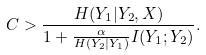Convert formula to latex. <formula><loc_0><loc_0><loc_500><loc_500>C > \frac { H ( Y _ { 1 } | Y _ { 2 } , X ) } { 1 + \frac { \alpha } { H ( Y _ { 2 } | Y _ { 1 } ) } I ( Y _ { 1 } ; Y _ { 2 } ) } .</formula> 